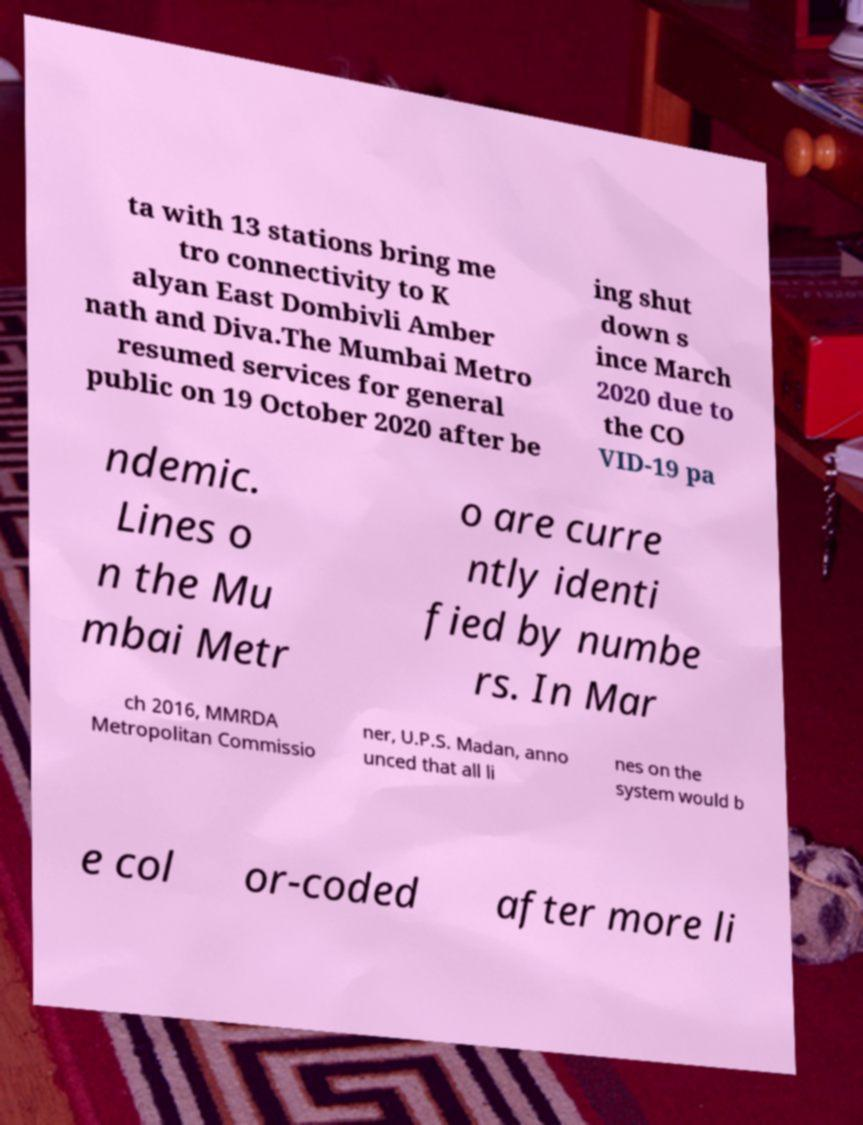Please identify and transcribe the text found in this image. ta with 13 stations bring me tro connectivity to K alyan East Dombivli Amber nath and Diva.The Mumbai Metro resumed services for general public on 19 October 2020 after be ing shut down s ince March 2020 due to the CO VID-19 pa ndemic. Lines o n the Mu mbai Metr o are curre ntly identi fied by numbe rs. In Mar ch 2016, MMRDA Metropolitan Commissio ner, U.P.S. Madan, anno unced that all li nes on the system would b e col or-coded after more li 